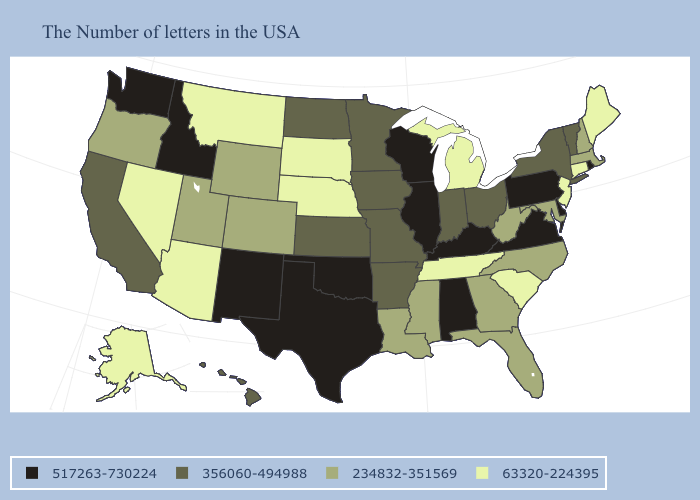Name the states that have a value in the range 234832-351569?
Write a very short answer. Massachusetts, New Hampshire, Maryland, North Carolina, West Virginia, Florida, Georgia, Mississippi, Louisiana, Wyoming, Colorado, Utah, Oregon. What is the value of Missouri?
Be succinct. 356060-494988. Name the states that have a value in the range 63320-224395?
Write a very short answer. Maine, Connecticut, New Jersey, South Carolina, Michigan, Tennessee, Nebraska, South Dakota, Montana, Arizona, Nevada, Alaska. What is the value of North Dakota?
Concise answer only. 356060-494988. Name the states that have a value in the range 517263-730224?
Short answer required. Rhode Island, Delaware, Pennsylvania, Virginia, Kentucky, Alabama, Wisconsin, Illinois, Oklahoma, Texas, New Mexico, Idaho, Washington. Which states have the highest value in the USA?
Write a very short answer. Rhode Island, Delaware, Pennsylvania, Virginia, Kentucky, Alabama, Wisconsin, Illinois, Oklahoma, Texas, New Mexico, Idaho, Washington. What is the value of New York?
Short answer required. 356060-494988. Does the map have missing data?
Answer briefly. No. Name the states that have a value in the range 356060-494988?
Give a very brief answer. Vermont, New York, Ohio, Indiana, Missouri, Arkansas, Minnesota, Iowa, Kansas, North Dakota, California, Hawaii. What is the value of Alabama?
Write a very short answer. 517263-730224. Name the states that have a value in the range 517263-730224?
Write a very short answer. Rhode Island, Delaware, Pennsylvania, Virginia, Kentucky, Alabama, Wisconsin, Illinois, Oklahoma, Texas, New Mexico, Idaho, Washington. Name the states that have a value in the range 63320-224395?
Quick response, please. Maine, Connecticut, New Jersey, South Carolina, Michigan, Tennessee, Nebraska, South Dakota, Montana, Arizona, Nevada, Alaska. What is the value of Ohio?
Give a very brief answer. 356060-494988. How many symbols are there in the legend?
Quick response, please. 4. Name the states that have a value in the range 517263-730224?
Short answer required. Rhode Island, Delaware, Pennsylvania, Virginia, Kentucky, Alabama, Wisconsin, Illinois, Oklahoma, Texas, New Mexico, Idaho, Washington. 